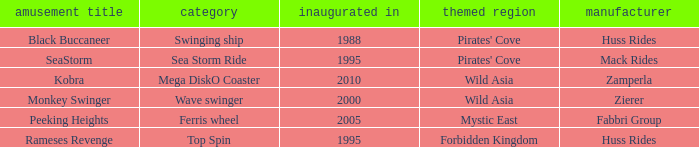What sort of attraction is rameses revenge? Top Spin. 